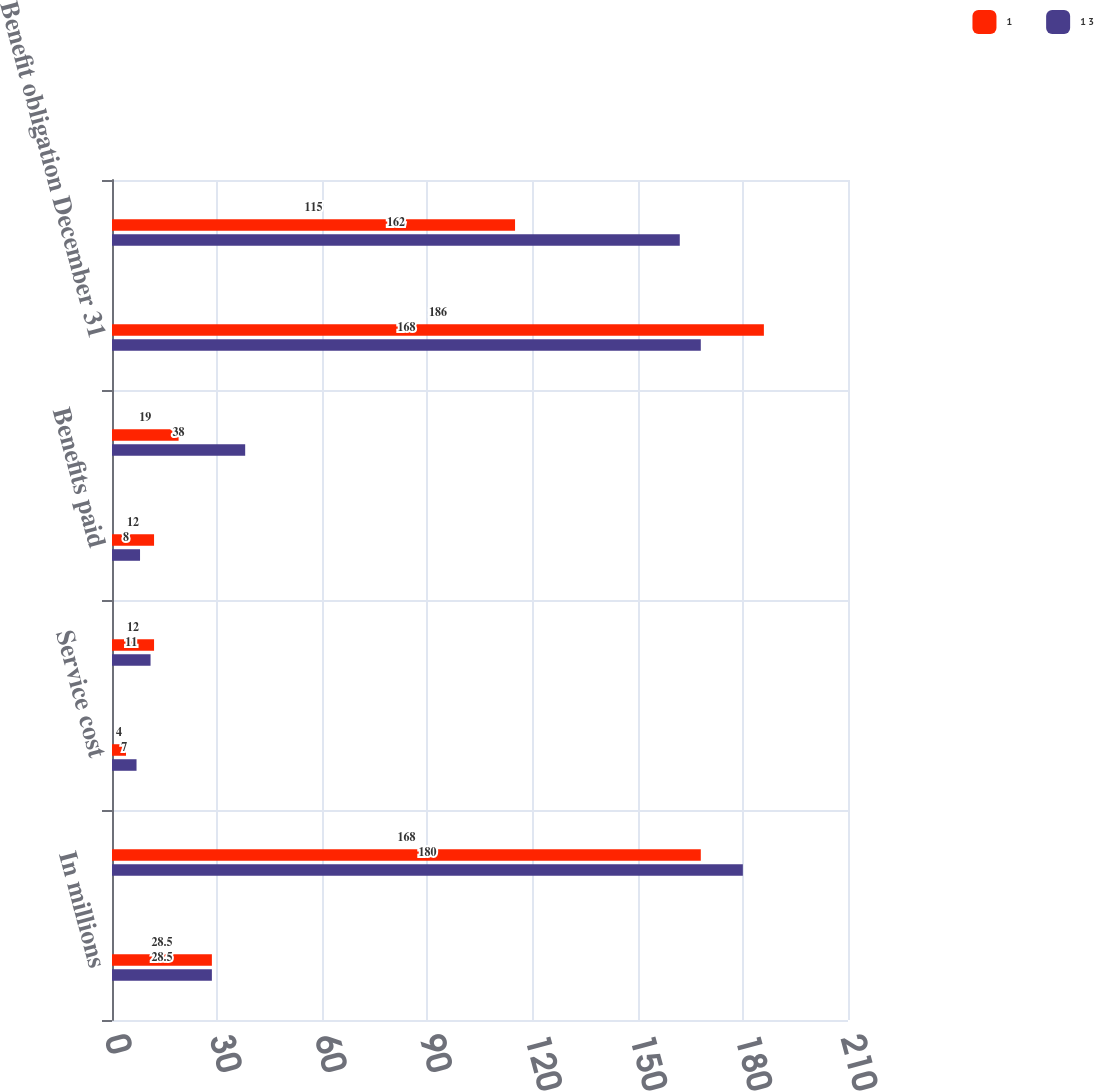<chart> <loc_0><loc_0><loc_500><loc_500><stacked_bar_chart><ecel><fcel>In millions<fcel>Benefit obligation January 1<fcel>Service cost<fcel>Interest cost<fcel>Benefits paid<fcel>Effect of foreign currency<fcel>Benefit obligation December 31<fcel>Fair value of plan assets<nl><fcel>1<fcel>28.5<fcel>168<fcel>4<fcel>12<fcel>12<fcel>19<fcel>186<fcel>115<nl><fcel>1 3<fcel>28.5<fcel>180<fcel>7<fcel>11<fcel>8<fcel>38<fcel>168<fcel>162<nl></chart> 